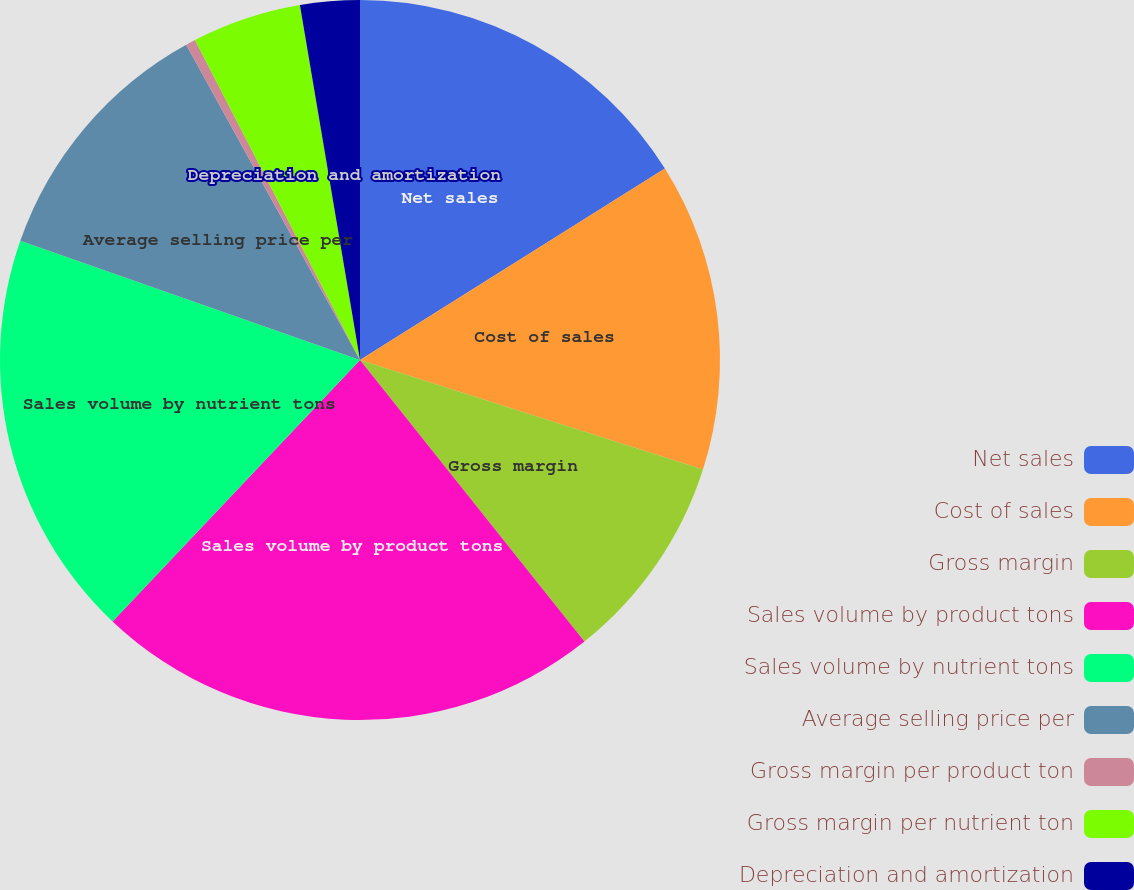<chart> <loc_0><loc_0><loc_500><loc_500><pie_chart><fcel>Net sales<fcel>Cost of sales<fcel>Gross margin<fcel>Sales volume by product tons<fcel>Sales volume by nutrient tons<fcel>Average selling price per<fcel>Gross margin per product ton<fcel>Gross margin per nutrient ton<fcel>Depreciation and amortization<nl><fcel>16.08%<fcel>13.84%<fcel>9.37%<fcel>22.78%<fcel>18.31%<fcel>11.61%<fcel>0.44%<fcel>4.91%<fcel>2.67%<nl></chart> 